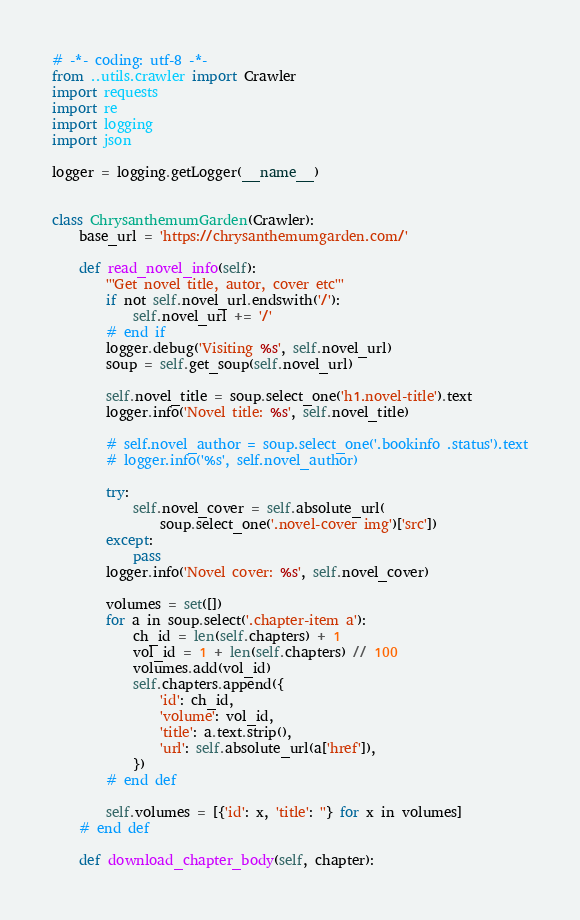<code> <loc_0><loc_0><loc_500><loc_500><_Python_># -*- coding: utf-8 -*-
from ..utils.crawler import Crawler
import requests
import re
import logging
import json

logger = logging.getLogger(__name__)


class ChrysanthemumGarden(Crawler):
    base_url = 'https://chrysanthemumgarden.com/'

    def read_novel_info(self):
        '''Get novel title, autor, cover etc'''
        if not self.novel_url.endswith('/'):
            self.novel_url += '/'
        # end if
        logger.debug('Visiting %s', self.novel_url)
        soup = self.get_soup(self.novel_url)

        self.novel_title = soup.select_one('h1.novel-title').text
        logger.info('Novel title: %s', self.novel_title)

        # self.novel_author = soup.select_one('.bookinfo .status').text
        # logger.info('%s', self.novel_author)

        try:
            self.novel_cover = self.absolute_url(
                soup.select_one('.novel-cover img')['src'])
        except:
            pass
        logger.info('Novel cover: %s', self.novel_cover)

        volumes = set([])
        for a in soup.select('.chapter-item a'):
            ch_id = len(self.chapters) + 1
            vol_id = 1 + len(self.chapters) // 100
            volumes.add(vol_id)
            self.chapters.append({
                'id': ch_id,
                'volume': vol_id,
                'title': a.text.strip(),
                'url': self.absolute_url(a['href']),
            })
        # end def

        self.volumes = [{'id': x, 'title': ''} for x in volumes]
    # end def

    def download_chapter_body(self, chapter):</code> 